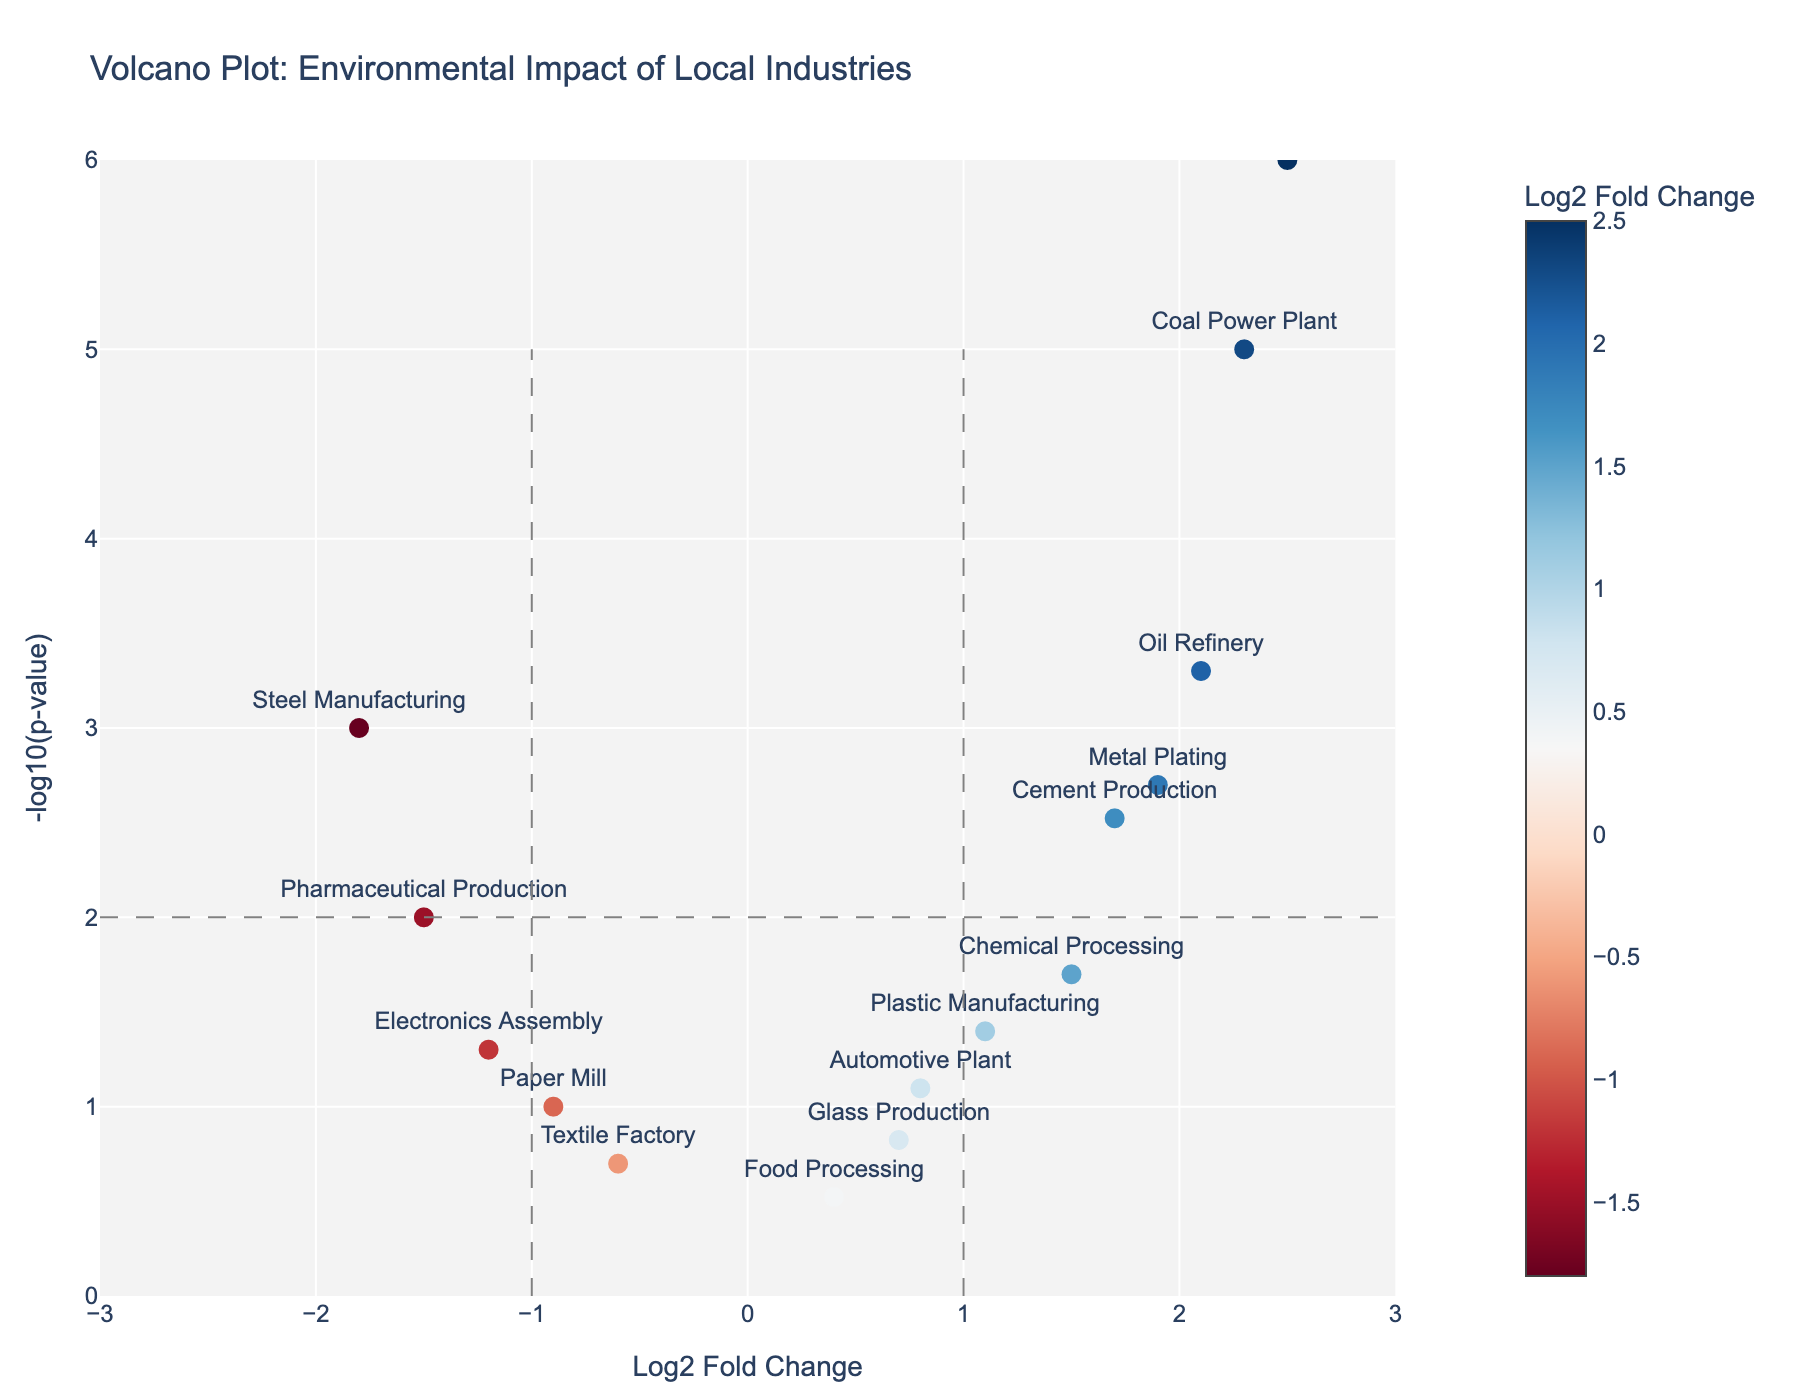What is the title of the plot? The title of the plot is displayed at the top of the figure.
Answer: Volcano Plot: Environmental Impact of Local Industries How many industries are represented in the plot? Count the number of data points (markers) in the plot to determine how many industries are represented.
Answer: 15 Which industry has the highest -log10(p-value)? Identify the data point with the highest y-axis value; the hover text can help confirm the industry.
Answer: Waste Incineration Are there any industries with negative Log2 Fold Change values and significant p-values (p < 0.05)? Look for data points to the left of the vertical line at x = -1 and above the horizontal line at y = 2.
Answer: Steel Manufacturing, Pharmaceutical Production Which industry has the most significant positive Log2 Fold Change? Find the data point with the highest x-axis value; the hover text can help confirm the industry.
Answer: Waste Incineration Compare the Log2 Fold Change between Chemical Processing and Oil Refinery industries. Which is larger? Check the x-axis values of both industries; Chemical Processing = 1.5, Oil Refinery = 2.1.
Answer: Oil Refinery What is the p-value for the Automotive Plant industry? Hover over the data point for Automotive Plant to see its p-value in the hover text.
Answer: 0.08 How does the p-value of the Textile Factory compare to that of the Food Processing industry? Compare the y-axis values of both industries; Textile Factory's y-value is higher than Food Processing.
Answer: Textile Factory has a lower p-value Which industries are clustered near the center of the plot (close to the origin)? Look for data points near (0, 0) on the plot.
Answer: Food Processing, Glass Production What color scale is used for the data points, and what does it represent? The plot uses a color scale from red to blue to represent different Log2 Fold Change values.
Answer: RdBu color scale for Log2 Fold Change 